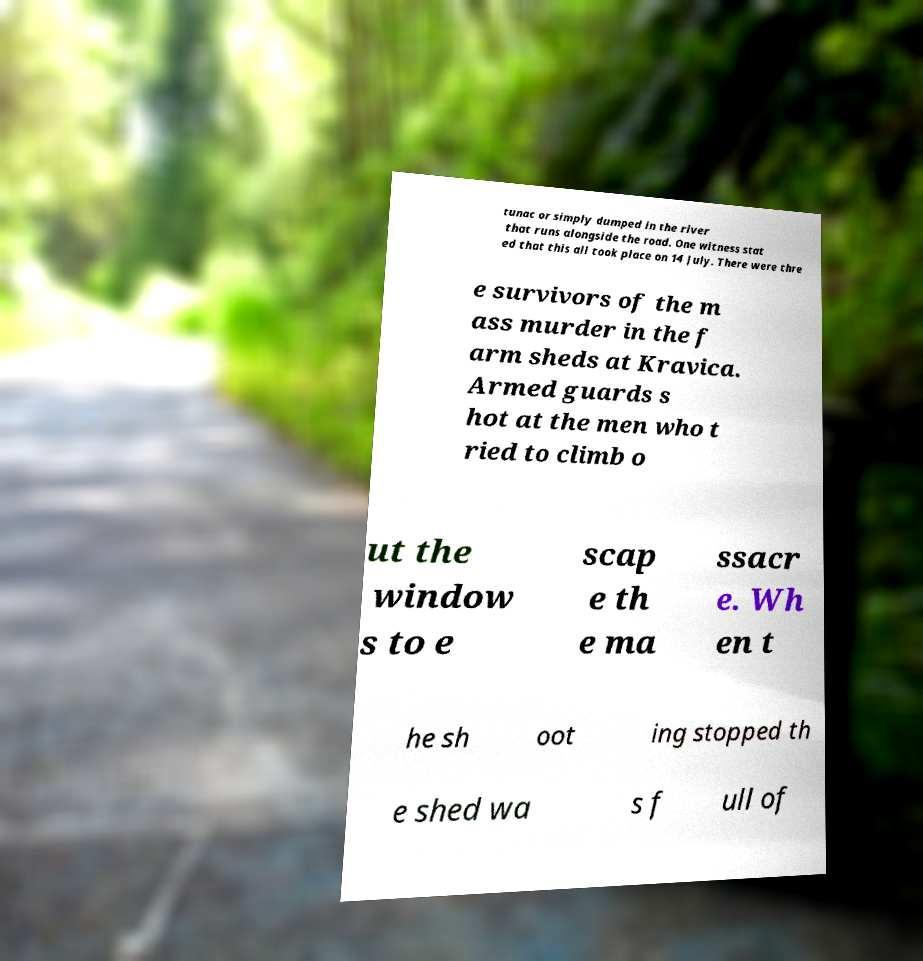Could you extract and type out the text from this image? tunac or simply dumped in the river that runs alongside the road. One witness stat ed that this all took place on 14 July. There were thre e survivors of the m ass murder in the f arm sheds at Kravica. Armed guards s hot at the men who t ried to climb o ut the window s to e scap e th e ma ssacr e. Wh en t he sh oot ing stopped th e shed wa s f ull of 